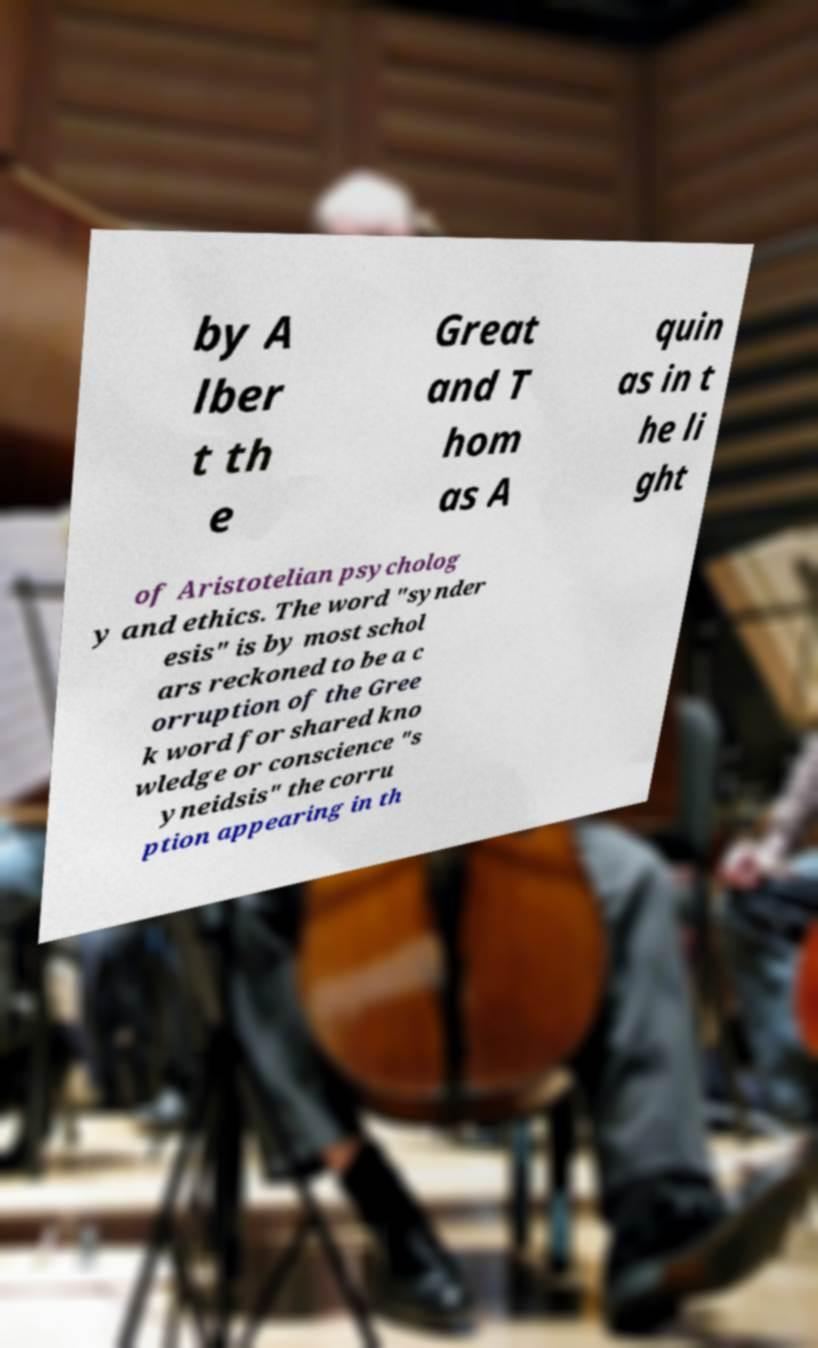Please read and relay the text visible in this image. What does it say? by A lber t th e Great and T hom as A quin as in t he li ght of Aristotelian psycholog y and ethics. The word "synder esis" is by most schol ars reckoned to be a c orruption of the Gree k word for shared kno wledge or conscience "s yneidsis" the corru ption appearing in th 